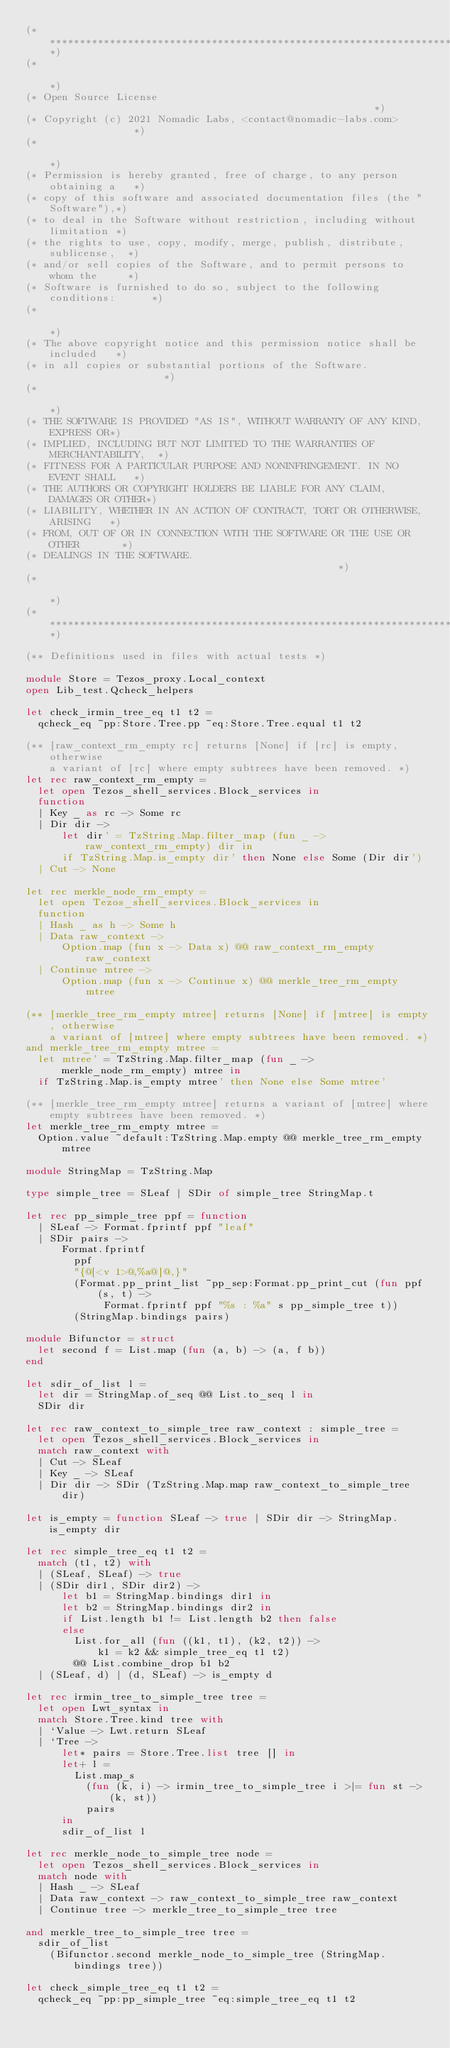<code> <loc_0><loc_0><loc_500><loc_500><_OCaml_>(*****************************************************************************)
(*                                                                           *)
(* Open Source License                                                       *)
(* Copyright (c) 2021 Nomadic Labs, <contact@nomadic-labs.com>               *)
(*                                                                           *)
(* Permission is hereby granted, free of charge, to any person obtaining a   *)
(* copy of this software and associated documentation files (the "Software"),*)
(* to deal in the Software without restriction, including without limitation *)
(* the rights to use, copy, modify, merge, publish, distribute, sublicense,  *)
(* and/or sell copies of the Software, and to permit persons to whom the     *)
(* Software is furnished to do so, subject to the following conditions:      *)
(*                                                                           *)
(* The above copyright notice and this permission notice shall be included   *)
(* in all copies or substantial portions of the Software.                    *)
(*                                                                           *)
(* THE SOFTWARE IS PROVIDED "AS IS", WITHOUT WARRANTY OF ANY KIND, EXPRESS OR*)
(* IMPLIED, INCLUDING BUT NOT LIMITED TO THE WARRANTIES OF MERCHANTABILITY,  *)
(* FITNESS FOR A PARTICULAR PURPOSE AND NONINFRINGEMENT. IN NO EVENT SHALL   *)
(* THE AUTHORS OR COPYRIGHT HOLDERS BE LIABLE FOR ANY CLAIM, DAMAGES OR OTHER*)
(* LIABILITY, WHETHER IN AN ACTION OF CONTRACT, TORT OR OTHERWISE, ARISING   *)
(* FROM, OUT OF OR IN CONNECTION WITH THE SOFTWARE OR THE USE OR OTHER       *)
(* DEALINGS IN THE SOFTWARE.                                                 *)
(*                                                                           *)
(*****************************************************************************)

(** Definitions used in files with actual tests *)

module Store = Tezos_proxy.Local_context
open Lib_test.Qcheck_helpers

let check_irmin_tree_eq t1 t2 =
  qcheck_eq ~pp:Store.Tree.pp ~eq:Store.Tree.equal t1 t2

(** [raw_context_rm_empty rc] returns [None] if [rc] is empty, otherwise
    a variant of [rc] where empty subtrees have been removed. *)
let rec raw_context_rm_empty =
  let open Tezos_shell_services.Block_services in
  function
  | Key _ as rc -> Some rc
  | Dir dir ->
      let dir' = TzString.Map.filter_map (fun _ -> raw_context_rm_empty) dir in
      if TzString.Map.is_empty dir' then None else Some (Dir dir')
  | Cut -> None

let rec merkle_node_rm_empty =
  let open Tezos_shell_services.Block_services in
  function
  | Hash _ as h -> Some h
  | Data raw_context ->
      Option.map (fun x -> Data x) @@ raw_context_rm_empty raw_context
  | Continue mtree ->
      Option.map (fun x -> Continue x) @@ merkle_tree_rm_empty mtree

(** [merkle_tree_rm_empty mtree] returns [None] if [mtree] is empty, otherwise
    a variant of [mtree] where empty subtrees have been removed. *)
and merkle_tree_rm_empty mtree =
  let mtree' = TzString.Map.filter_map (fun _ -> merkle_node_rm_empty) mtree in
  if TzString.Map.is_empty mtree' then None else Some mtree'

(** [merkle_tree_rm_empty mtree] returns a variant of [mtree] where
    empty subtrees have been removed. *)
let merkle_tree_rm_empty mtree =
  Option.value ~default:TzString.Map.empty @@ merkle_tree_rm_empty mtree

module StringMap = TzString.Map

type simple_tree = SLeaf | SDir of simple_tree StringMap.t

let rec pp_simple_tree ppf = function
  | SLeaf -> Format.fprintf ppf "leaf"
  | SDir pairs ->
      Format.fprintf
        ppf
        "{@[<v 1>@,%a@]@,}"
        (Format.pp_print_list ~pp_sep:Format.pp_print_cut (fun ppf (s, t) ->
             Format.fprintf ppf "%s : %a" s pp_simple_tree t))
        (StringMap.bindings pairs)

module Bifunctor = struct
  let second f = List.map (fun (a, b) -> (a, f b))
end

let sdir_of_list l =
  let dir = StringMap.of_seq @@ List.to_seq l in
  SDir dir

let rec raw_context_to_simple_tree raw_context : simple_tree =
  let open Tezos_shell_services.Block_services in
  match raw_context with
  | Cut -> SLeaf
  | Key _ -> SLeaf
  | Dir dir -> SDir (TzString.Map.map raw_context_to_simple_tree dir)

let is_empty = function SLeaf -> true | SDir dir -> StringMap.is_empty dir

let rec simple_tree_eq t1 t2 =
  match (t1, t2) with
  | (SLeaf, SLeaf) -> true
  | (SDir dir1, SDir dir2) ->
      let b1 = StringMap.bindings dir1 in
      let b2 = StringMap.bindings dir2 in
      if List.length b1 != List.length b2 then false
      else
        List.for_all (fun ((k1, t1), (k2, t2)) ->
            k1 = k2 && simple_tree_eq t1 t2)
        @@ List.combine_drop b1 b2
  | (SLeaf, d) | (d, SLeaf) -> is_empty d

let rec irmin_tree_to_simple_tree tree =
  let open Lwt_syntax in
  match Store.Tree.kind tree with
  | `Value -> Lwt.return SLeaf
  | `Tree ->
      let* pairs = Store.Tree.list tree [] in
      let+ l =
        List.map_s
          (fun (k, i) -> irmin_tree_to_simple_tree i >|= fun st -> (k, st))
          pairs
      in
      sdir_of_list l

let rec merkle_node_to_simple_tree node =
  let open Tezos_shell_services.Block_services in
  match node with
  | Hash _ -> SLeaf
  | Data raw_context -> raw_context_to_simple_tree raw_context
  | Continue tree -> merkle_tree_to_simple_tree tree

and merkle_tree_to_simple_tree tree =
  sdir_of_list
    (Bifunctor.second merkle_node_to_simple_tree (StringMap.bindings tree))

let check_simple_tree_eq t1 t2 =
  qcheck_eq ~pp:pp_simple_tree ~eq:simple_tree_eq t1 t2
</code> 